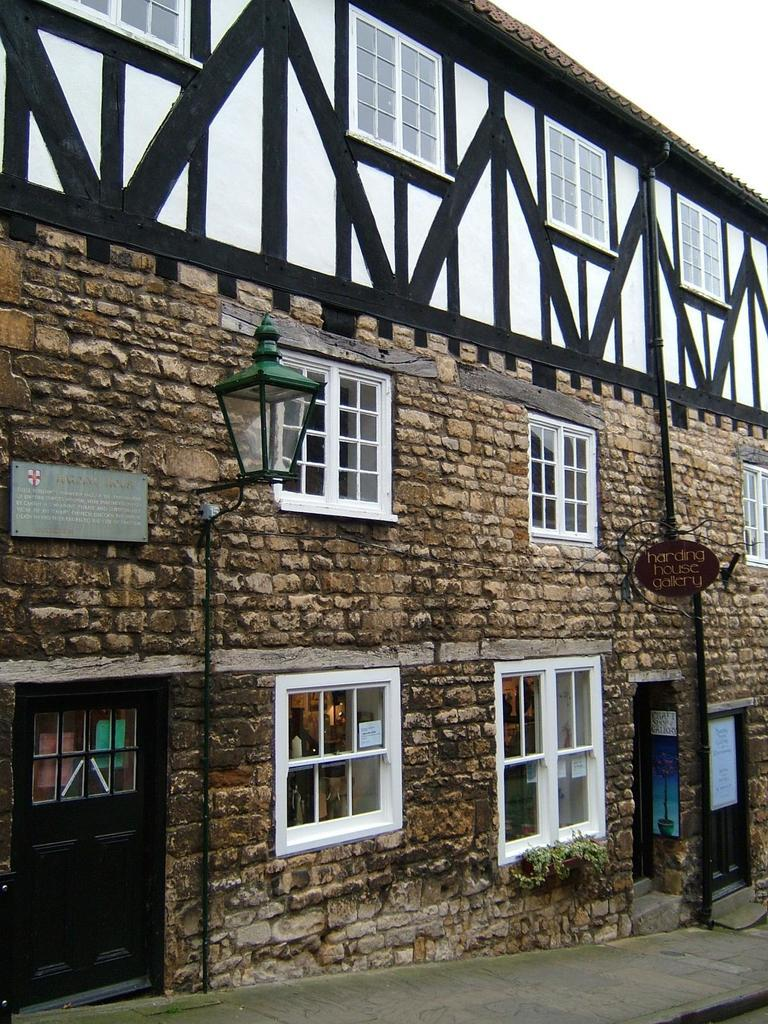What type of structure is present in the image? There is a building in the image. What features can be observed on the building? The building has windows and a door. What additional object can be seen in the image? There is a street lamp in the image. Can you describe the board on the wall? There is a board on a wall in the image. What type of vegetation is present in the image? There are plants in the image. What other signage can be seen in the image? There is a sign board on a pole in the image. Where is the shelf located in the image? There is no shelf present in the image. Can you describe the yak walking down the street in the image? There is no yak present in the image. 